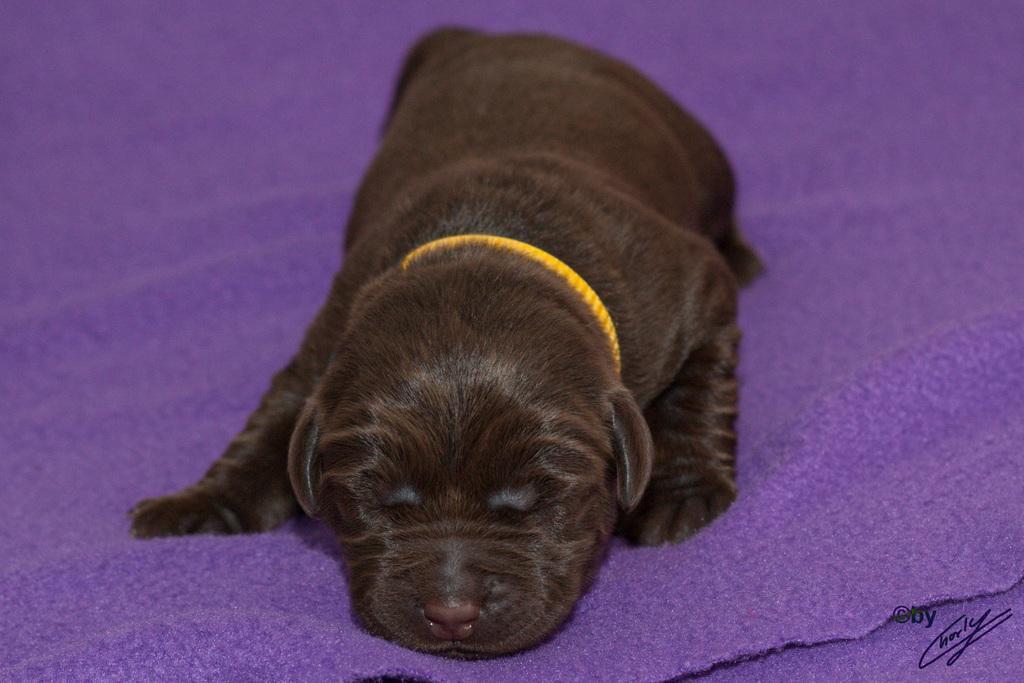Could you give a brief overview of what you see in this image? In this image there is a dog on the violet color carpet. At the bottom right side of the image there is some text. 